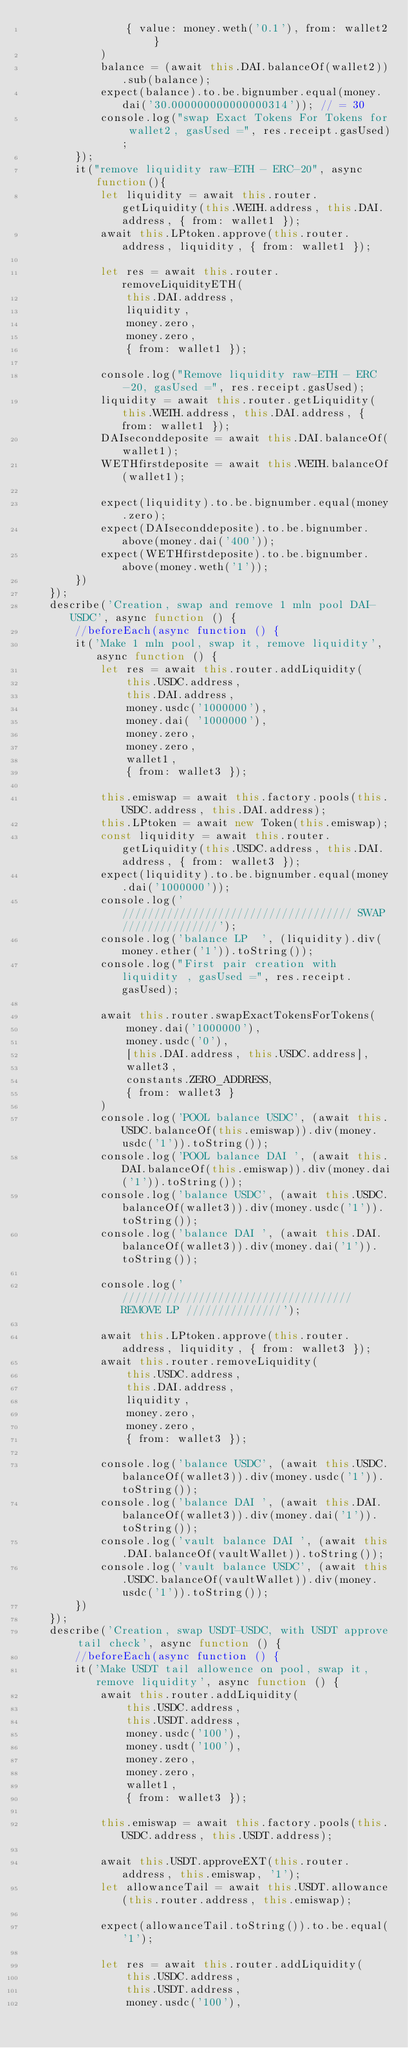Convert code to text. <code><loc_0><loc_0><loc_500><loc_500><_JavaScript_>                { value: money.weth('0.1'), from: wallet2 }
            )
            balance = (await this.DAI.balanceOf(wallet2)).sub(balance);
            expect(balance).to.be.bignumber.equal(money.dai('30.000000000000000314')); // = 30
            console.log("swap Exact Tokens For Tokens for wallet2, gasUsed =", res.receipt.gasUsed);
        });
        it("remove liquidity raw-ETH - ERC-20", async function(){
            let liquidity = await this.router.getLiquidity(this.WETH.address, this.DAI.address, { from: wallet1 });
            await this.LPtoken.approve(this.router.address, liquidity, { from: wallet1 });

            let res = await this.router.removeLiquidityETH(
                this.DAI.address,
                liquidity,
                money.zero,
                money.zero,
                { from: wallet1 });
            
            console.log("Remove liquidity raw-ETH - ERC-20, gasUsed =", res.receipt.gasUsed);
            liquidity = await this.router.getLiquidity(this.WETH.address, this.DAI.address, { from: wallet1 });
            DAIseconddeposite = await this.DAI.balanceOf(wallet1);
            WETHfirstdeposite = await this.WETH.balanceOf(wallet1);

            expect(liquidity).to.be.bignumber.equal(money.zero);
            expect(DAIseconddeposite).to.be.bignumber.above(money.dai('400'));
            expect(WETHfirstdeposite).to.be.bignumber.above(money.weth('1'));
        })
    });
    describe('Creation, swap and remove 1 mln pool DAI-USDC', async function () {
        //beforeEach(async function () {
        it('Make 1 mln pool, swap it, remove liquidity', async function () {
            let res = await this.router.addLiquidity(
                this.USDC.address,
                this.DAI.address,
                money.usdc('1000000'),
                money.dai( '1000000'),
                money.zero,
                money.zero,
                wallet1,
                { from: wallet3 });

            this.emiswap = await this.factory.pools(this.USDC.address, this.DAI.address);
            this.LPtoken = await new Token(this.emiswap);
            const liquidity = await this.router.getLiquidity(this.USDC.address, this.DAI.address, { from: wallet3 });
            expect(liquidity).to.be.bignumber.equal(money.dai('1000000'));
            console.log('//////////////////////////////////// SWAP ///////////////');
            console.log('balance LP  ', (liquidity).div(money.ether('1')).toString());
            console.log("First pair creation with liquidity , gasUsed =", res.receipt.gasUsed);

            await this.router.swapExactTokensForTokens(
                money.dai('1000000'),
                money.usdc('0'),
                [this.DAI.address, this.USDC.address],
                wallet3,
                constants.ZERO_ADDRESS,
                { from: wallet3 }
            )
            console.log('POOL balance USDC', (await this.USDC.balanceOf(this.emiswap)).div(money.usdc('1')).toString());
            console.log('POOL balance DAI ', (await this.DAI.balanceOf(this.emiswap)).div(money.dai('1')).toString());
            console.log('balance USDC', (await this.USDC.balanceOf(wallet3)).div(money.usdc('1')).toString());
            console.log('balance DAI ', (await this.DAI.balanceOf(wallet3)).div(money.dai('1')).toString());

            console.log('//////////////////////////////////// REMOVE LP ///////////////');

            await this.LPtoken.approve(this.router.address, liquidity, { from: wallet3 });
            await this.router.removeLiquidity(
                this.USDC.address, 
                this.DAI.address,
                liquidity,
                money.zero,
                money.zero,
                { from: wallet3 });

            console.log('balance USDC', (await this.USDC.balanceOf(wallet3)).div(money.usdc('1')).toString());
            console.log('balance DAI ', (await this.DAI.balanceOf(wallet3)).div(money.dai('1')).toString());
            console.log('vault balance DAI ', (await this.DAI.balanceOf(vaultWallet)).toString());
            console.log('vault balance USDC', (await this.USDC.balanceOf(vaultWallet)).div(money.usdc('1')).toString());
        })
    });
    describe('Creation, swap USDT-USDC, with USDT approve tail check', async function () {
        //beforeEach(async function () {
        it('Make USDT tail allowence on pool, swap it, remove liquidity', async function () {            
            await this.router.addLiquidity(
                this.USDC.address,
                this.USDT.address,
                money.usdc('100'),
                money.usdt('100'),
                money.zero,
                money.zero,
                wallet1,
                { from: wallet3 });

            this.emiswap = await this.factory.pools(this.USDC.address, this.USDT.address);

            await this.USDT.approveEXT(this.router.address, this.emiswap, '1');
            let allowanceTail = await this.USDT.allowance(this.router.address, this.emiswap);

            expect(allowanceTail.toString()).to.be.equal('1');

            let res = await this.router.addLiquidity(
                this.USDC.address,
                this.USDT.address,
                money.usdc('100'),</code> 